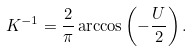Convert formula to latex. <formula><loc_0><loc_0><loc_500><loc_500>K ^ { - 1 } = \frac { 2 } { \pi } \arccos \left ( - \frac { U } { 2 } \right ) .</formula> 